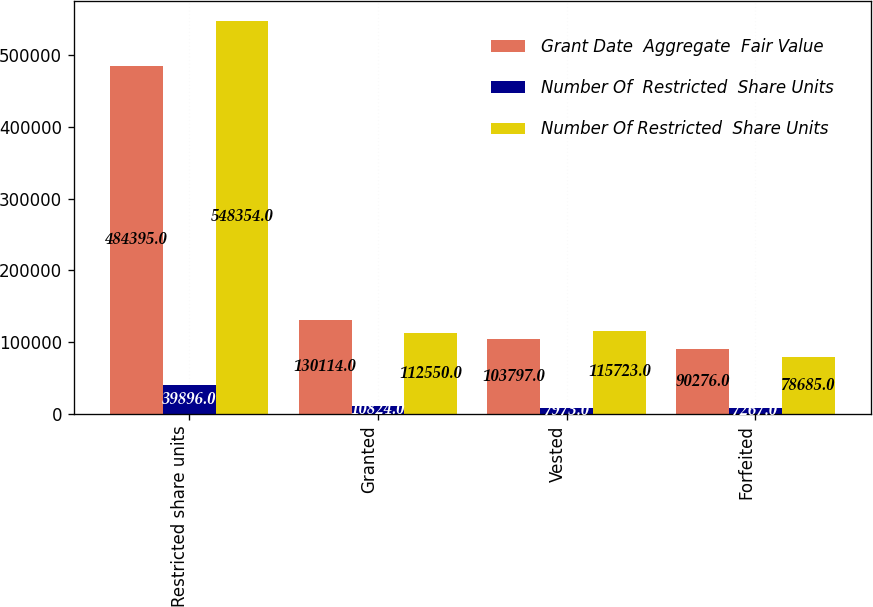<chart> <loc_0><loc_0><loc_500><loc_500><stacked_bar_chart><ecel><fcel>Restricted share units<fcel>Granted<fcel>Vested<fcel>Forfeited<nl><fcel>Grant Date  Aggregate  Fair Value<fcel>484395<fcel>130114<fcel>103797<fcel>90276<nl><fcel>Number Of  Restricted  Share Units<fcel>39896<fcel>10824<fcel>7973<fcel>7267<nl><fcel>Number Of Restricted  Share Units<fcel>548354<fcel>112550<fcel>115723<fcel>78685<nl></chart> 